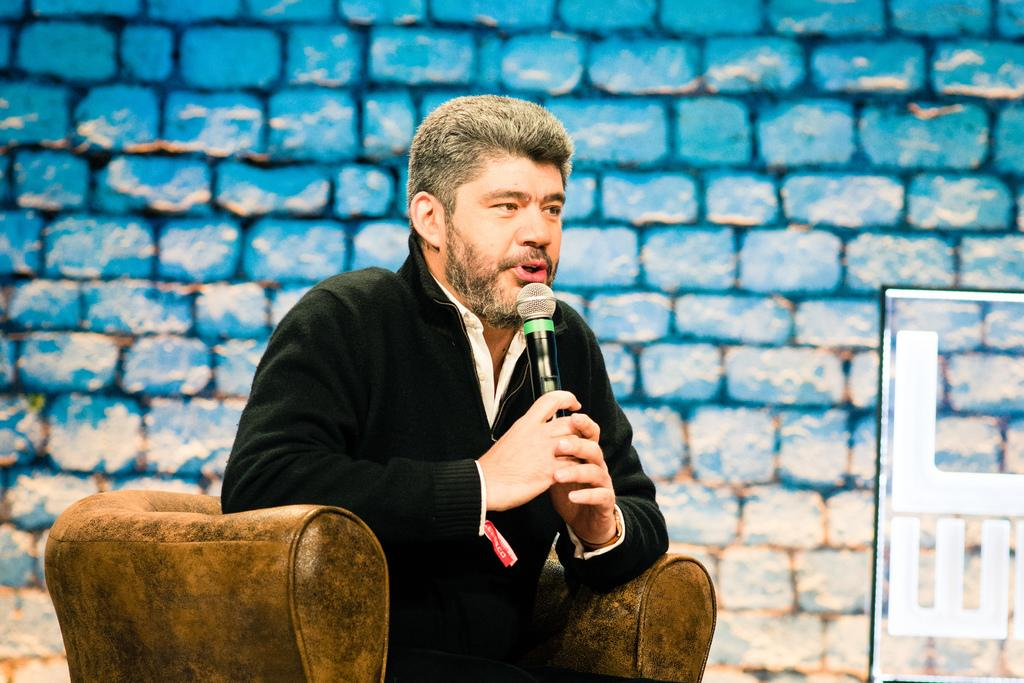What is the person in the image doing? The person is sitting on a sofa chair and holding a mic. What can be seen behind the person in the image? There is a brick wall in the background of the image. What is on the right side of the image? There is a glass wall with letters on the right side of the image. What type of steel is used to construct the temper in the battle scene depicted in the image? There is no battle scene or steel construction present in the image; it features a person sitting on a sofa chair holding a mic. 